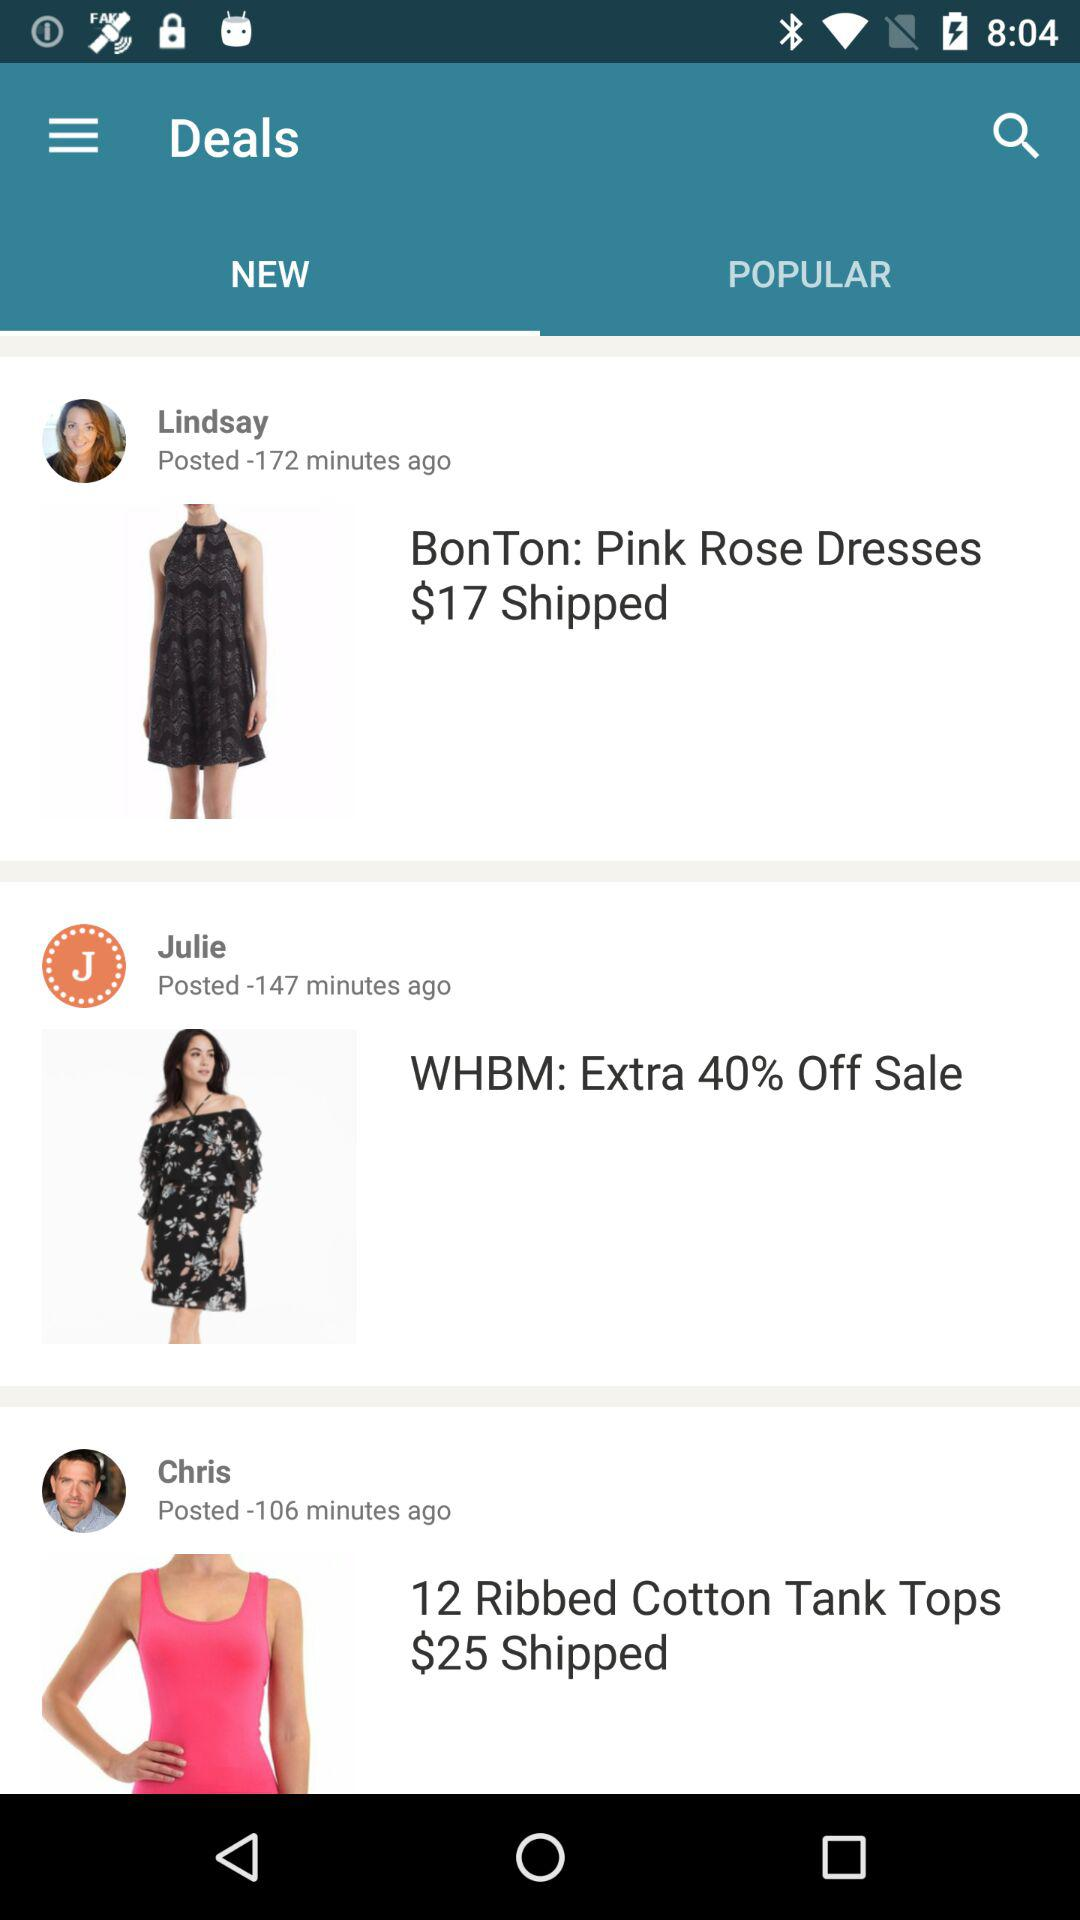Which tab is selected? The selected tab is "NEW". 